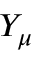Convert formula to latex. <formula><loc_0><loc_0><loc_500><loc_500>Y _ { \mu }</formula> 